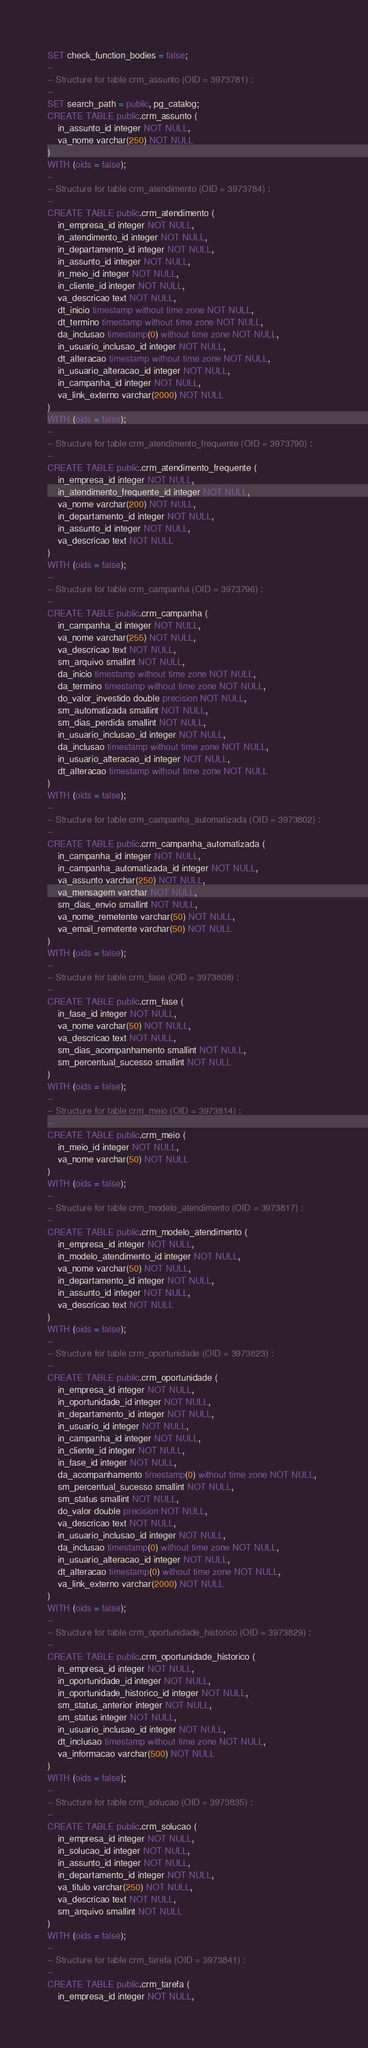Convert code to text. <code><loc_0><loc_0><loc_500><loc_500><_SQL_>SET check_function_bodies = false;
--
-- Structure for table crm_assunto (OID = 3973781) :
--
SET search_path = public, pg_catalog;
CREATE TABLE public.crm_assunto (
    in_assunto_id integer NOT NULL,
    va_nome varchar(250) NOT NULL
)
WITH (oids = false);
--
-- Structure for table crm_atendimento (OID = 3973784) :
--
CREATE TABLE public.crm_atendimento (
    in_empresa_id integer NOT NULL,
    in_atendimento_id integer NOT NULL,
    in_departamento_id integer NOT NULL,
    in_assunto_id integer NOT NULL,
    in_meio_id integer NOT NULL,
    in_cliente_id integer NOT NULL,
    va_descricao text NOT NULL,
    dt_inicio timestamp without time zone NOT NULL,
    dt_termino timestamp without time zone NOT NULL,
    da_inclusao timestamp(0) without time zone NOT NULL,
    in_usuario_inclusao_id integer NOT NULL,
    dt_alteracao timestamp without time zone NOT NULL,
    in_usuario_alteracao_id integer NOT NULL,
    in_campanha_id integer NOT NULL,
    va_link_externo varchar(2000) NOT NULL
)
WITH (oids = false);
--
-- Structure for table crm_atendimento_frequente (OID = 3973790) :
--
CREATE TABLE public.crm_atendimento_frequente (
    in_empresa_id integer NOT NULL,
    in_atendimento_frequente_id integer NOT NULL,
    va_nome varchar(200) NOT NULL,
    in_departamento_id integer NOT NULL,
    in_assunto_id integer NOT NULL,
    va_descricao text NOT NULL
)
WITH (oids = false);
--
-- Structure for table crm_campanha (OID = 3973796) :
--
CREATE TABLE public.crm_campanha (
    in_campanha_id integer NOT NULL,
    va_nome varchar(255) NOT NULL,
    va_descricao text NOT NULL,
    sm_arquivo smallint NOT NULL,
    da_inicio timestamp without time zone NOT NULL,
    da_termino timestamp without time zone NOT NULL,
    do_valor_investido double precision NOT NULL,
    sm_automatizada smallint NOT NULL,
    sm_dias_perdida smallint NOT NULL,
    in_usuario_inclusao_id integer NOT NULL,
    da_inclusao timestamp without time zone NOT NULL,
    in_usuario_alteracao_id integer NOT NULL,
    dt_alteracao timestamp without time zone NOT NULL
)
WITH (oids = false);
--
-- Structure for table crm_campanha_automatizada (OID = 3973802) :
--
CREATE TABLE public.crm_campanha_automatizada (
    in_campanha_id integer NOT NULL,
    in_campanha_automatizada_id integer NOT NULL,
    va_assunto varchar(250) NOT NULL,
    va_mensagem varchar NOT NULL,
    sm_dias_envio smallint NOT NULL,
    va_nome_remetente varchar(50) NOT NULL,
    va_email_remetente varchar(50) NOT NULL
)
WITH (oids = false);
--
-- Structure for table crm_fase (OID = 3973808) :
--
CREATE TABLE public.crm_fase (
    in_fase_id integer NOT NULL,
    va_nome varchar(50) NOT NULL,
    va_descricao text NOT NULL,
    sm_dias_acompanhamento smallint NOT NULL,
    sm_percentual_sucesso smallint NOT NULL
)
WITH (oids = false);
--
-- Structure for table crm_meio (OID = 3973814) :
--
CREATE TABLE public.crm_meio (
    in_meio_id integer NOT NULL,
    va_nome varchar(50) NOT NULL
)
WITH (oids = false);
--
-- Structure for table crm_modelo_atendimento (OID = 3973817) :
--
CREATE TABLE public.crm_modelo_atendimento (
    in_empresa_id integer NOT NULL,
    in_modelo_atendimento_id integer NOT NULL,
    va_nome varchar(50) NOT NULL,
    in_departamento_id integer NOT NULL,
    in_assunto_id integer NOT NULL,
    va_descricao text NOT NULL
)
WITH (oids = false);
--
-- Structure for table crm_oportunidade (OID = 3973823) :
--
CREATE TABLE public.crm_oportunidade (
    in_empresa_id integer NOT NULL,
    in_oportunidade_id integer NOT NULL,
    in_departamento_id integer NOT NULL,
    in_usuario_id integer NOT NULL,
    in_campanha_id integer NOT NULL,
    in_cliente_id integer NOT NULL,
    in_fase_id integer NOT NULL,
    da_acompanhamento timestamp(0) without time zone NOT NULL,
    sm_percentual_sucesso smallint NOT NULL,
    sm_status smallint NOT NULL,
    do_valor double precision NOT NULL,
    va_descricao text NOT NULL,
    in_usuario_inclusao_id integer NOT NULL,
    da_inclusao timestamp(0) without time zone NOT NULL,
    in_usuario_alteracao_id integer NOT NULL,
    dt_alteracao timestamp(0) without time zone NOT NULL,
    va_link_externo varchar(2000) NOT NULL
)
WITH (oids = false);
--
-- Structure for table crm_oportunidade_historico (OID = 3973829) :
--
CREATE TABLE public.crm_oportunidade_historico (
    in_empresa_id integer NOT NULL,
    in_oportunidade_id integer NOT NULL,
    in_oportunidade_historico_id integer NOT NULL,
    sm_status_anterior integer NOT NULL,
    sm_status integer NOT NULL,
    in_usuario_inclusao_id integer NOT NULL,
    dt_inclusao timestamp without time zone NOT NULL,
    va_informacao varchar(500) NOT NULL
)
WITH (oids = false);
--
-- Structure for table crm_solucao (OID = 3973835) :
--
CREATE TABLE public.crm_solucao (
    in_empresa_id integer NOT NULL,
    in_solucao_id integer NOT NULL,
    in_assunto_id integer NOT NULL,
    in_departamento_id integer NOT NULL,
    va_titulo varchar(250) NOT NULL,
    va_descricao text NOT NULL,
    sm_arquivo smallint NOT NULL
)
WITH (oids = false);
--
-- Structure for table crm_tarefa (OID = 3973841) :
--
CREATE TABLE public.crm_tarefa (
    in_empresa_id integer NOT NULL,</code> 